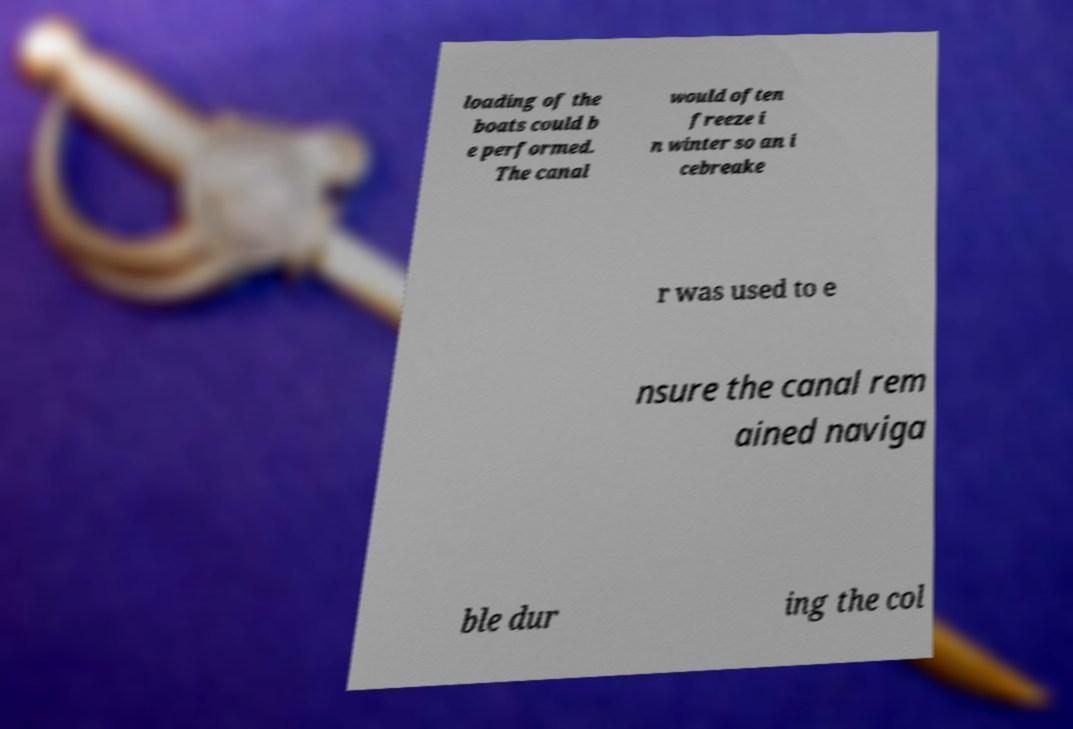Can you read and provide the text displayed in the image?This photo seems to have some interesting text. Can you extract and type it out for me? loading of the boats could b e performed. The canal would often freeze i n winter so an i cebreake r was used to e nsure the canal rem ained naviga ble dur ing the col 